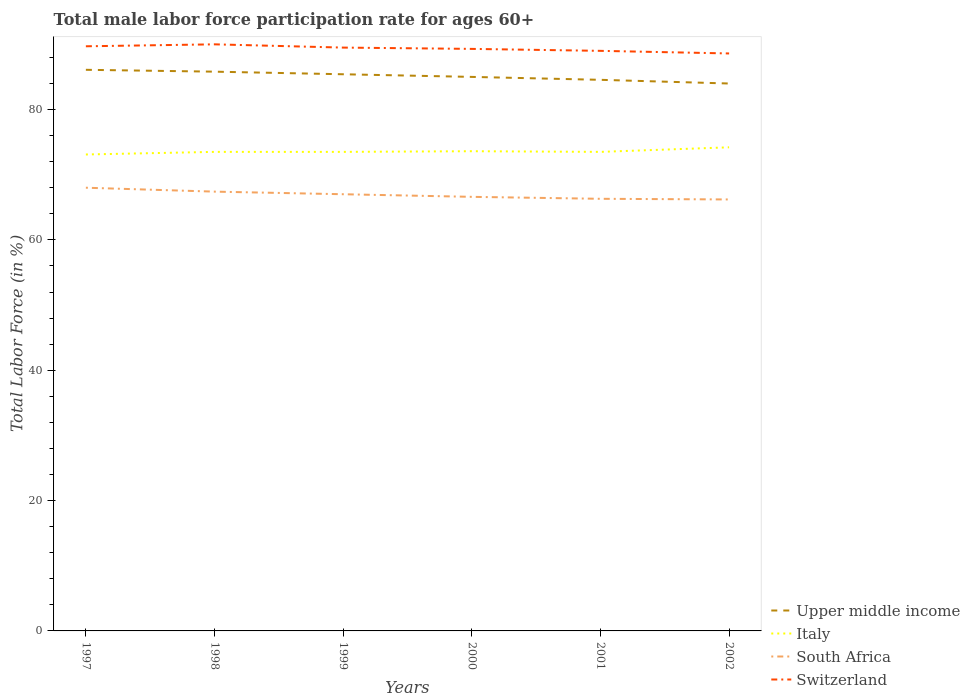Does the line corresponding to Italy intersect with the line corresponding to South Africa?
Ensure brevity in your answer.  No. Across all years, what is the maximum male labor force participation rate in Switzerland?
Your answer should be compact. 88.6. What is the total male labor force participation rate in Switzerland in the graph?
Your response must be concise. 0.5. What is the difference between the highest and the second highest male labor force participation rate in Italy?
Your response must be concise. 1.1. What is the difference between the highest and the lowest male labor force participation rate in Upper middle income?
Make the answer very short. 3. Is the male labor force participation rate in South Africa strictly greater than the male labor force participation rate in Upper middle income over the years?
Provide a short and direct response. Yes. Are the values on the major ticks of Y-axis written in scientific E-notation?
Offer a terse response. No. Does the graph contain grids?
Offer a very short reply. No. Where does the legend appear in the graph?
Your answer should be compact. Bottom right. How many legend labels are there?
Provide a short and direct response. 4. What is the title of the graph?
Your answer should be very brief. Total male labor force participation rate for ages 60+. What is the Total Labor Force (in %) in Upper middle income in 1997?
Offer a terse response. 86.09. What is the Total Labor Force (in %) in Italy in 1997?
Your answer should be very brief. 73.1. What is the Total Labor Force (in %) of Switzerland in 1997?
Provide a short and direct response. 89.7. What is the Total Labor Force (in %) in Upper middle income in 1998?
Give a very brief answer. 85.81. What is the Total Labor Force (in %) of Italy in 1998?
Give a very brief answer. 73.5. What is the Total Labor Force (in %) of South Africa in 1998?
Provide a short and direct response. 67.4. What is the Total Labor Force (in %) in Switzerland in 1998?
Offer a very short reply. 90. What is the Total Labor Force (in %) in Upper middle income in 1999?
Your answer should be compact. 85.41. What is the Total Labor Force (in %) of Italy in 1999?
Your answer should be very brief. 73.5. What is the Total Labor Force (in %) in South Africa in 1999?
Your answer should be compact. 67. What is the Total Labor Force (in %) in Switzerland in 1999?
Your response must be concise. 89.5. What is the Total Labor Force (in %) in Upper middle income in 2000?
Provide a short and direct response. 85. What is the Total Labor Force (in %) in Italy in 2000?
Give a very brief answer. 73.6. What is the Total Labor Force (in %) of South Africa in 2000?
Your response must be concise. 66.6. What is the Total Labor Force (in %) of Switzerland in 2000?
Your response must be concise. 89.3. What is the Total Labor Force (in %) in Upper middle income in 2001?
Your response must be concise. 84.55. What is the Total Labor Force (in %) of Italy in 2001?
Provide a succinct answer. 73.5. What is the Total Labor Force (in %) of South Africa in 2001?
Your answer should be very brief. 66.3. What is the Total Labor Force (in %) in Switzerland in 2001?
Offer a very short reply. 89. What is the Total Labor Force (in %) in Upper middle income in 2002?
Make the answer very short. 83.99. What is the Total Labor Force (in %) in Italy in 2002?
Provide a short and direct response. 74.2. What is the Total Labor Force (in %) of South Africa in 2002?
Your answer should be very brief. 66.2. What is the Total Labor Force (in %) of Switzerland in 2002?
Make the answer very short. 88.6. Across all years, what is the maximum Total Labor Force (in %) in Upper middle income?
Provide a succinct answer. 86.09. Across all years, what is the maximum Total Labor Force (in %) in Italy?
Provide a succinct answer. 74.2. Across all years, what is the maximum Total Labor Force (in %) of South Africa?
Your answer should be very brief. 68. Across all years, what is the maximum Total Labor Force (in %) of Switzerland?
Ensure brevity in your answer.  90. Across all years, what is the minimum Total Labor Force (in %) in Upper middle income?
Make the answer very short. 83.99. Across all years, what is the minimum Total Labor Force (in %) in Italy?
Keep it short and to the point. 73.1. Across all years, what is the minimum Total Labor Force (in %) of South Africa?
Offer a very short reply. 66.2. Across all years, what is the minimum Total Labor Force (in %) of Switzerland?
Provide a short and direct response. 88.6. What is the total Total Labor Force (in %) in Upper middle income in the graph?
Give a very brief answer. 510.85. What is the total Total Labor Force (in %) in Italy in the graph?
Make the answer very short. 441.4. What is the total Total Labor Force (in %) in South Africa in the graph?
Make the answer very short. 401.5. What is the total Total Labor Force (in %) of Switzerland in the graph?
Make the answer very short. 536.1. What is the difference between the Total Labor Force (in %) of Upper middle income in 1997 and that in 1998?
Make the answer very short. 0.29. What is the difference between the Total Labor Force (in %) of South Africa in 1997 and that in 1998?
Provide a short and direct response. 0.6. What is the difference between the Total Labor Force (in %) of Upper middle income in 1997 and that in 1999?
Make the answer very short. 0.68. What is the difference between the Total Labor Force (in %) of Switzerland in 1997 and that in 1999?
Provide a short and direct response. 0.2. What is the difference between the Total Labor Force (in %) of Upper middle income in 1997 and that in 2000?
Keep it short and to the point. 1.09. What is the difference between the Total Labor Force (in %) of Italy in 1997 and that in 2000?
Your response must be concise. -0.5. What is the difference between the Total Labor Force (in %) in Upper middle income in 1997 and that in 2001?
Provide a succinct answer. 1.54. What is the difference between the Total Labor Force (in %) in Switzerland in 1997 and that in 2001?
Offer a very short reply. 0.7. What is the difference between the Total Labor Force (in %) of Upper middle income in 1997 and that in 2002?
Keep it short and to the point. 2.1. What is the difference between the Total Labor Force (in %) in Switzerland in 1997 and that in 2002?
Your answer should be very brief. 1.1. What is the difference between the Total Labor Force (in %) in Upper middle income in 1998 and that in 1999?
Keep it short and to the point. 0.4. What is the difference between the Total Labor Force (in %) in Italy in 1998 and that in 1999?
Offer a very short reply. 0. What is the difference between the Total Labor Force (in %) in South Africa in 1998 and that in 1999?
Make the answer very short. 0.4. What is the difference between the Total Labor Force (in %) of Upper middle income in 1998 and that in 2000?
Ensure brevity in your answer.  0.8. What is the difference between the Total Labor Force (in %) in Switzerland in 1998 and that in 2000?
Provide a short and direct response. 0.7. What is the difference between the Total Labor Force (in %) of Upper middle income in 1998 and that in 2001?
Keep it short and to the point. 1.25. What is the difference between the Total Labor Force (in %) of South Africa in 1998 and that in 2001?
Offer a very short reply. 1.1. What is the difference between the Total Labor Force (in %) of Upper middle income in 1998 and that in 2002?
Provide a succinct answer. 1.82. What is the difference between the Total Labor Force (in %) in Italy in 1998 and that in 2002?
Provide a short and direct response. -0.7. What is the difference between the Total Labor Force (in %) of Switzerland in 1998 and that in 2002?
Ensure brevity in your answer.  1.4. What is the difference between the Total Labor Force (in %) in Upper middle income in 1999 and that in 2000?
Offer a very short reply. 0.41. What is the difference between the Total Labor Force (in %) in Italy in 1999 and that in 2000?
Keep it short and to the point. -0.1. What is the difference between the Total Labor Force (in %) in Switzerland in 1999 and that in 2000?
Offer a terse response. 0.2. What is the difference between the Total Labor Force (in %) in Upper middle income in 1999 and that in 2001?
Keep it short and to the point. 0.85. What is the difference between the Total Labor Force (in %) of South Africa in 1999 and that in 2001?
Provide a short and direct response. 0.7. What is the difference between the Total Labor Force (in %) of Switzerland in 1999 and that in 2001?
Ensure brevity in your answer.  0.5. What is the difference between the Total Labor Force (in %) of Upper middle income in 1999 and that in 2002?
Your response must be concise. 1.42. What is the difference between the Total Labor Force (in %) of Italy in 1999 and that in 2002?
Provide a succinct answer. -0.7. What is the difference between the Total Labor Force (in %) of Switzerland in 1999 and that in 2002?
Your answer should be very brief. 0.9. What is the difference between the Total Labor Force (in %) of Upper middle income in 2000 and that in 2001?
Keep it short and to the point. 0.45. What is the difference between the Total Labor Force (in %) of Switzerland in 2000 and that in 2001?
Your answer should be compact. 0.3. What is the difference between the Total Labor Force (in %) in Upper middle income in 2000 and that in 2002?
Your answer should be compact. 1.01. What is the difference between the Total Labor Force (in %) in South Africa in 2000 and that in 2002?
Offer a very short reply. 0.4. What is the difference between the Total Labor Force (in %) of Upper middle income in 2001 and that in 2002?
Keep it short and to the point. 0.57. What is the difference between the Total Labor Force (in %) of Italy in 2001 and that in 2002?
Keep it short and to the point. -0.7. What is the difference between the Total Labor Force (in %) of Upper middle income in 1997 and the Total Labor Force (in %) of Italy in 1998?
Offer a terse response. 12.59. What is the difference between the Total Labor Force (in %) in Upper middle income in 1997 and the Total Labor Force (in %) in South Africa in 1998?
Offer a terse response. 18.69. What is the difference between the Total Labor Force (in %) in Upper middle income in 1997 and the Total Labor Force (in %) in Switzerland in 1998?
Offer a terse response. -3.91. What is the difference between the Total Labor Force (in %) of Italy in 1997 and the Total Labor Force (in %) of South Africa in 1998?
Your response must be concise. 5.7. What is the difference between the Total Labor Force (in %) in Italy in 1997 and the Total Labor Force (in %) in Switzerland in 1998?
Make the answer very short. -16.9. What is the difference between the Total Labor Force (in %) of South Africa in 1997 and the Total Labor Force (in %) of Switzerland in 1998?
Make the answer very short. -22. What is the difference between the Total Labor Force (in %) in Upper middle income in 1997 and the Total Labor Force (in %) in Italy in 1999?
Provide a short and direct response. 12.59. What is the difference between the Total Labor Force (in %) of Upper middle income in 1997 and the Total Labor Force (in %) of South Africa in 1999?
Offer a very short reply. 19.09. What is the difference between the Total Labor Force (in %) of Upper middle income in 1997 and the Total Labor Force (in %) of Switzerland in 1999?
Offer a terse response. -3.41. What is the difference between the Total Labor Force (in %) in Italy in 1997 and the Total Labor Force (in %) in Switzerland in 1999?
Offer a terse response. -16.4. What is the difference between the Total Labor Force (in %) of South Africa in 1997 and the Total Labor Force (in %) of Switzerland in 1999?
Offer a terse response. -21.5. What is the difference between the Total Labor Force (in %) of Upper middle income in 1997 and the Total Labor Force (in %) of Italy in 2000?
Your answer should be compact. 12.49. What is the difference between the Total Labor Force (in %) of Upper middle income in 1997 and the Total Labor Force (in %) of South Africa in 2000?
Offer a very short reply. 19.49. What is the difference between the Total Labor Force (in %) in Upper middle income in 1997 and the Total Labor Force (in %) in Switzerland in 2000?
Your answer should be compact. -3.21. What is the difference between the Total Labor Force (in %) in Italy in 1997 and the Total Labor Force (in %) in South Africa in 2000?
Offer a very short reply. 6.5. What is the difference between the Total Labor Force (in %) in Italy in 1997 and the Total Labor Force (in %) in Switzerland in 2000?
Your answer should be very brief. -16.2. What is the difference between the Total Labor Force (in %) in South Africa in 1997 and the Total Labor Force (in %) in Switzerland in 2000?
Offer a terse response. -21.3. What is the difference between the Total Labor Force (in %) of Upper middle income in 1997 and the Total Labor Force (in %) of Italy in 2001?
Provide a succinct answer. 12.59. What is the difference between the Total Labor Force (in %) of Upper middle income in 1997 and the Total Labor Force (in %) of South Africa in 2001?
Ensure brevity in your answer.  19.79. What is the difference between the Total Labor Force (in %) of Upper middle income in 1997 and the Total Labor Force (in %) of Switzerland in 2001?
Ensure brevity in your answer.  -2.91. What is the difference between the Total Labor Force (in %) of Italy in 1997 and the Total Labor Force (in %) of South Africa in 2001?
Offer a very short reply. 6.8. What is the difference between the Total Labor Force (in %) of Italy in 1997 and the Total Labor Force (in %) of Switzerland in 2001?
Your answer should be very brief. -15.9. What is the difference between the Total Labor Force (in %) of South Africa in 1997 and the Total Labor Force (in %) of Switzerland in 2001?
Offer a terse response. -21. What is the difference between the Total Labor Force (in %) of Upper middle income in 1997 and the Total Labor Force (in %) of Italy in 2002?
Your answer should be very brief. 11.89. What is the difference between the Total Labor Force (in %) of Upper middle income in 1997 and the Total Labor Force (in %) of South Africa in 2002?
Provide a succinct answer. 19.89. What is the difference between the Total Labor Force (in %) of Upper middle income in 1997 and the Total Labor Force (in %) of Switzerland in 2002?
Provide a short and direct response. -2.51. What is the difference between the Total Labor Force (in %) in Italy in 1997 and the Total Labor Force (in %) in Switzerland in 2002?
Keep it short and to the point. -15.5. What is the difference between the Total Labor Force (in %) of South Africa in 1997 and the Total Labor Force (in %) of Switzerland in 2002?
Offer a terse response. -20.6. What is the difference between the Total Labor Force (in %) in Upper middle income in 1998 and the Total Labor Force (in %) in Italy in 1999?
Give a very brief answer. 12.31. What is the difference between the Total Labor Force (in %) of Upper middle income in 1998 and the Total Labor Force (in %) of South Africa in 1999?
Keep it short and to the point. 18.81. What is the difference between the Total Labor Force (in %) in Upper middle income in 1998 and the Total Labor Force (in %) in Switzerland in 1999?
Your answer should be compact. -3.69. What is the difference between the Total Labor Force (in %) in Italy in 1998 and the Total Labor Force (in %) in South Africa in 1999?
Keep it short and to the point. 6.5. What is the difference between the Total Labor Force (in %) of South Africa in 1998 and the Total Labor Force (in %) of Switzerland in 1999?
Your response must be concise. -22.1. What is the difference between the Total Labor Force (in %) of Upper middle income in 1998 and the Total Labor Force (in %) of Italy in 2000?
Provide a succinct answer. 12.21. What is the difference between the Total Labor Force (in %) of Upper middle income in 1998 and the Total Labor Force (in %) of South Africa in 2000?
Your answer should be very brief. 19.21. What is the difference between the Total Labor Force (in %) of Upper middle income in 1998 and the Total Labor Force (in %) of Switzerland in 2000?
Your response must be concise. -3.49. What is the difference between the Total Labor Force (in %) in Italy in 1998 and the Total Labor Force (in %) in South Africa in 2000?
Your answer should be very brief. 6.9. What is the difference between the Total Labor Force (in %) in Italy in 1998 and the Total Labor Force (in %) in Switzerland in 2000?
Offer a very short reply. -15.8. What is the difference between the Total Labor Force (in %) of South Africa in 1998 and the Total Labor Force (in %) of Switzerland in 2000?
Provide a succinct answer. -21.9. What is the difference between the Total Labor Force (in %) in Upper middle income in 1998 and the Total Labor Force (in %) in Italy in 2001?
Make the answer very short. 12.31. What is the difference between the Total Labor Force (in %) in Upper middle income in 1998 and the Total Labor Force (in %) in South Africa in 2001?
Your answer should be compact. 19.51. What is the difference between the Total Labor Force (in %) in Upper middle income in 1998 and the Total Labor Force (in %) in Switzerland in 2001?
Ensure brevity in your answer.  -3.19. What is the difference between the Total Labor Force (in %) in Italy in 1998 and the Total Labor Force (in %) in Switzerland in 2001?
Give a very brief answer. -15.5. What is the difference between the Total Labor Force (in %) in South Africa in 1998 and the Total Labor Force (in %) in Switzerland in 2001?
Provide a succinct answer. -21.6. What is the difference between the Total Labor Force (in %) in Upper middle income in 1998 and the Total Labor Force (in %) in Italy in 2002?
Keep it short and to the point. 11.61. What is the difference between the Total Labor Force (in %) in Upper middle income in 1998 and the Total Labor Force (in %) in South Africa in 2002?
Provide a succinct answer. 19.61. What is the difference between the Total Labor Force (in %) in Upper middle income in 1998 and the Total Labor Force (in %) in Switzerland in 2002?
Keep it short and to the point. -2.79. What is the difference between the Total Labor Force (in %) of Italy in 1998 and the Total Labor Force (in %) of South Africa in 2002?
Make the answer very short. 7.3. What is the difference between the Total Labor Force (in %) of Italy in 1998 and the Total Labor Force (in %) of Switzerland in 2002?
Provide a short and direct response. -15.1. What is the difference between the Total Labor Force (in %) of South Africa in 1998 and the Total Labor Force (in %) of Switzerland in 2002?
Offer a very short reply. -21.2. What is the difference between the Total Labor Force (in %) of Upper middle income in 1999 and the Total Labor Force (in %) of Italy in 2000?
Provide a short and direct response. 11.81. What is the difference between the Total Labor Force (in %) of Upper middle income in 1999 and the Total Labor Force (in %) of South Africa in 2000?
Offer a very short reply. 18.81. What is the difference between the Total Labor Force (in %) of Upper middle income in 1999 and the Total Labor Force (in %) of Switzerland in 2000?
Give a very brief answer. -3.89. What is the difference between the Total Labor Force (in %) of Italy in 1999 and the Total Labor Force (in %) of Switzerland in 2000?
Your response must be concise. -15.8. What is the difference between the Total Labor Force (in %) of South Africa in 1999 and the Total Labor Force (in %) of Switzerland in 2000?
Provide a short and direct response. -22.3. What is the difference between the Total Labor Force (in %) in Upper middle income in 1999 and the Total Labor Force (in %) in Italy in 2001?
Offer a terse response. 11.91. What is the difference between the Total Labor Force (in %) of Upper middle income in 1999 and the Total Labor Force (in %) of South Africa in 2001?
Offer a terse response. 19.11. What is the difference between the Total Labor Force (in %) in Upper middle income in 1999 and the Total Labor Force (in %) in Switzerland in 2001?
Offer a very short reply. -3.59. What is the difference between the Total Labor Force (in %) of Italy in 1999 and the Total Labor Force (in %) of Switzerland in 2001?
Give a very brief answer. -15.5. What is the difference between the Total Labor Force (in %) in Upper middle income in 1999 and the Total Labor Force (in %) in Italy in 2002?
Your answer should be very brief. 11.21. What is the difference between the Total Labor Force (in %) in Upper middle income in 1999 and the Total Labor Force (in %) in South Africa in 2002?
Give a very brief answer. 19.21. What is the difference between the Total Labor Force (in %) in Upper middle income in 1999 and the Total Labor Force (in %) in Switzerland in 2002?
Provide a succinct answer. -3.19. What is the difference between the Total Labor Force (in %) of Italy in 1999 and the Total Labor Force (in %) of Switzerland in 2002?
Offer a terse response. -15.1. What is the difference between the Total Labor Force (in %) of South Africa in 1999 and the Total Labor Force (in %) of Switzerland in 2002?
Make the answer very short. -21.6. What is the difference between the Total Labor Force (in %) in Upper middle income in 2000 and the Total Labor Force (in %) in Italy in 2001?
Give a very brief answer. 11.5. What is the difference between the Total Labor Force (in %) in Upper middle income in 2000 and the Total Labor Force (in %) in South Africa in 2001?
Give a very brief answer. 18.7. What is the difference between the Total Labor Force (in %) of Upper middle income in 2000 and the Total Labor Force (in %) of Switzerland in 2001?
Ensure brevity in your answer.  -4. What is the difference between the Total Labor Force (in %) of Italy in 2000 and the Total Labor Force (in %) of South Africa in 2001?
Provide a succinct answer. 7.3. What is the difference between the Total Labor Force (in %) of Italy in 2000 and the Total Labor Force (in %) of Switzerland in 2001?
Ensure brevity in your answer.  -15.4. What is the difference between the Total Labor Force (in %) in South Africa in 2000 and the Total Labor Force (in %) in Switzerland in 2001?
Offer a terse response. -22.4. What is the difference between the Total Labor Force (in %) of Upper middle income in 2000 and the Total Labor Force (in %) of Italy in 2002?
Provide a succinct answer. 10.8. What is the difference between the Total Labor Force (in %) of Upper middle income in 2000 and the Total Labor Force (in %) of South Africa in 2002?
Provide a succinct answer. 18.8. What is the difference between the Total Labor Force (in %) of Upper middle income in 2000 and the Total Labor Force (in %) of Switzerland in 2002?
Give a very brief answer. -3.6. What is the difference between the Total Labor Force (in %) in Italy in 2000 and the Total Labor Force (in %) in South Africa in 2002?
Your answer should be compact. 7.4. What is the difference between the Total Labor Force (in %) in South Africa in 2000 and the Total Labor Force (in %) in Switzerland in 2002?
Ensure brevity in your answer.  -22. What is the difference between the Total Labor Force (in %) of Upper middle income in 2001 and the Total Labor Force (in %) of Italy in 2002?
Provide a short and direct response. 10.35. What is the difference between the Total Labor Force (in %) of Upper middle income in 2001 and the Total Labor Force (in %) of South Africa in 2002?
Your answer should be compact. 18.35. What is the difference between the Total Labor Force (in %) in Upper middle income in 2001 and the Total Labor Force (in %) in Switzerland in 2002?
Give a very brief answer. -4.05. What is the difference between the Total Labor Force (in %) of Italy in 2001 and the Total Labor Force (in %) of South Africa in 2002?
Your answer should be compact. 7.3. What is the difference between the Total Labor Force (in %) in Italy in 2001 and the Total Labor Force (in %) in Switzerland in 2002?
Your answer should be compact. -15.1. What is the difference between the Total Labor Force (in %) in South Africa in 2001 and the Total Labor Force (in %) in Switzerland in 2002?
Keep it short and to the point. -22.3. What is the average Total Labor Force (in %) in Upper middle income per year?
Keep it short and to the point. 85.14. What is the average Total Labor Force (in %) of Italy per year?
Make the answer very short. 73.57. What is the average Total Labor Force (in %) in South Africa per year?
Provide a short and direct response. 66.92. What is the average Total Labor Force (in %) in Switzerland per year?
Offer a terse response. 89.35. In the year 1997, what is the difference between the Total Labor Force (in %) of Upper middle income and Total Labor Force (in %) of Italy?
Your response must be concise. 12.99. In the year 1997, what is the difference between the Total Labor Force (in %) of Upper middle income and Total Labor Force (in %) of South Africa?
Your response must be concise. 18.09. In the year 1997, what is the difference between the Total Labor Force (in %) in Upper middle income and Total Labor Force (in %) in Switzerland?
Offer a terse response. -3.61. In the year 1997, what is the difference between the Total Labor Force (in %) in Italy and Total Labor Force (in %) in Switzerland?
Keep it short and to the point. -16.6. In the year 1997, what is the difference between the Total Labor Force (in %) of South Africa and Total Labor Force (in %) of Switzerland?
Give a very brief answer. -21.7. In the year 1998, what is the difference between the Total Labor Force (in %) of Upper middle income and Total Labor Force (in %) of Italy?
Provide a succinct answer. 12.31. In the year 1998, what is the difference between the Total Labor Force (in %) in Upper middle income and Total Labor Force (in %) in South Africa?
Your response must be concise. 18.41. In the year 1998, what is the difference between the Total Labor Force (in %) of Upper middle income and Total Labor Force (in %) of Switzerland?
Keep it short and to the point. -4.19. In the year 1998, what is the difference between the Total Labor Force (in %) in Italy and Total Labor Force (in %) in South Africa?
Give a very brief answer. 6.1. In the year 1998, what is the difference between the Total Labor Force (in %) of Italy and Total Labor Force (in %) of Switzerland?
Provide a short and direct response. -16.5. In the year 1998, what is the difference between the Total Labor Force (in %) of South Africa and Total Labor Force (in %) of Switzerland?
Offer a very short reply. -22.6. In the year 1999, what is the difference between the Total Labor Force (in %) in Upper middle income and Total Labor Force (in %) in Italy?
Your response must be concise. 11.91. In the year 1999, what is the difference between the Total Labor Force (in %) in Upper middle income and Total Labor Force (in %) in South Africa?
Ensure brevity in your answer.  18.41. In the year 1999, what is the difference between the Total Labor Force (in %) in Upper middle income and Total Labor Force (in %) in Switzerland?
Your answer should be compact. -4.09. In the year 1999, what is the difference between the Total Labor Force (in %) in Italy and Total Labor Force (in %) in South Africa?
Your answer should be compact. 6.5. In the year 1999, what is the difference between the Total Labor Force (in %) in South Africa and Total Labor Force (in %) in Switzerland?
Provide a succinct answer. -22.5. In the year 2000, what is the difference between the Total Labor Force (in %) of Upper middle income and Total Labor Force (in %) of Italy?
Offer a very short reply. 11.4. In the year 2000, what is the difference between the Total Labor Force (in %) of Upper middle income and Total Labor Force (in %) of South Africa?
Your answer should be compact. 18.4. In the year 2000, what is the difference between the Total Labor Force (in %) in Upper middle income and Total Labor Force (in %) in Switzerland?
Offer a very short reply. -4.3. In the year 2000, what is the difference between the Total Labor Force (in %) in Italy and Total Labor Force (in %) in Switzerland?
Offer a terse response. -15.7. In the year 2000, what is the difference between the Total Labor Force (in %) in South Africa and Total Labor Force (in %) in Switzerland?
Provide a short and direct response. -22.7. In the year 2001, what is the difference between the Total Labor Force (in %) of Upper middle income and Total Labor Force (in %) of Italy?
Your response must be concise. 11.05. In the year 2001, what is the difference between the Total Labor Force (in %) in Upper middle income and Total Labor Force (in %) in South Africa?
Your answer should be very brief. 18.25. In the year 2001, what is the difference between the Total Labor Force (in %) in Upper middle income and Total Labor Force (in %) in Switzerland?
Offer a very short reply. -4.45. In the year 2001, what is the difference between the Total Labor Force (in %) of Italy and Total Labor Force (in %) of Switzerland?
Give a very brief answer. -15.5. In the year 2001, what is the difference between the Total Labor Force (in %) in South Africa and Total Labor Force (in %) in Switzerland?
Your answer should be compact. -22.7. In the year 2002, what is the difference between the Total Labor Force (in %) in Upper middle income and Total Labor Force (in %) in Italy?
Provide a succinct answer. 9.79. In the year 2002, what is the difference between the Total Labor Force (in %) in Upper middle income and Total Labor Force (in %) in South Africa?
Your answer should be compact. 17.79. In the year 2002, what is the difference between the Total Labor Force (in %) in Upper middle income and Total Labor Force (in %) in Switzerland?
Your answer should be very brief. -4.61. In the year 2002, what is the difference between the Total Labor Force (in %) of Italy and Total Labor Force (in %) of South Africa?
Keep it short and to the point. 8. In the year 2002, what is the difference between the Total Labor Force (in %) of Italy and Total Labor Force (in %) of Switzerland?
Your answer should be compact. -14.4. In the year 2002, what is the difference between the Total Labor Force (in %) of South Africa and Total Labor Force (in %) of Switzerland?
Provide a succinct answer. -22.4. What is the ratio of the Total Labor Force (in %) of South Africa in 1997 to that in 1998?
Your answer should be compact. 1.01. What is the ratio of the Total Labor Force (in %) in Switzerland in 1997 to that in 1998?
Ensure brevity in your answer.  1. What is the ratio of the Total Labor Force (in %) in South Africa in 1997 to that in 1999?
Make the answer very short. 1.01. What is the ratio of the Total Labor Force (in %) in Switzerland in 1997 to that in 1999?
Provide a short and direct response. 1. What is the ratio of the Total Labor Force (in %) in Upper middle income in 1997 to that in 2000?
Provide a succinct answer. 1.01. What is the ratio of the Total Labor Force (in %) of South Africa in 1997 to that in 2000?
Your answer should be very brief. 1.02. What is the ratio of the Total Labor Force (in %) of Upper middle income in 1997 to that in 2001?
Your answer should be compact. 1.02. What is the ratio of the Total Labor Force (in %) in Italy in 1997 to that in 2001?
Keep it short and to the point. 0.99. What is the ratio of the Total Labor Force (in %) of South Africa in 1997 to that in 2001?
Provide a short and direct response. 1.03. What is the ratio of the Total Labor Force (in %) of Switzerland in 1997 to that in 2001?
Your answer should be compact. 1.01. What is the ratio of the Total Labor Force (in %) of Italy in 1997 to that in 2002?
Offer a terse response. 0.99. What is the ratio of the Total Labor Force (in %) of South Africa in 1997 to that in 2002?
Offer a very short reply. 1.03. What is the ratio of the Total Labor Force (in %) in Switzerland in 1997 to that in 2002?
Ensure brevity in your answer.  1.01. What is the ratio of the Total Labor Force (in %) in South Africa in 1998 to that in 1999?
Ensure brevity in your answer.  1.01. What is the ratio of the Total Labor Force (in %) in Switzerland in 1998 to that in 1999?
Provide a succinct answer. 1.01. What is the ratio of the Total Labor Force (in %) of Upper middle income in 1998 to that in 2000?
Provide a short and direct response. 1.01. What is the ratio of the Total Labor Force (in %) of Italy in 1998 to that in 2000?
Offer a very short reply. 1. What is the ratio of the Total Labor Force (in %) of South Africa in 1998 to that in 2000?
Provide a succinct answer. 1.01. What is the ratio of the Total Labor Force (in %) of Switzerland in 1998 to that in 2000?
Provide a short and direct response. 1.01. What is the ratio of the Total Labor Force (in %) of Upper middle income in 1998 to that in 2001?
Your answer should be compact. 1.01. What is the ratio of the Total Labor Force (in %) of Italy in 1998 to that in 2001?
Make the answer very short. 1. What is the ratio of the Total Labor Force (in %) in South Africa in 1998 to that in 2001?
Ensure brevity in your answer.  1.02. What is the ratio of the Total Labor Force (in %) of Switzerland in 1998 to that in 2001?
Keep it short and to the point. 1.01. What is the ratio of the Total Labor Force (in %) of Upper middle income in 1998 to that in 2002?
Provide a succinct answer. 1.02. What is the ratio of the Total Labor Force (in %) of Italy in 1998 to that in 2002?
Offer a terse response. 0.99. What is the ratio of the Total Labor Force (in %) of South Africa in 1998 to that in 2002?
Offer a very short reply. 1.02. What is the ratio of the Total Labor Force (in %) of Switzerland in 1998 to that in 2002?
Your response must be concise. 1.02. What is the ratio of the Total Labor Force (in %) in Italy in 1999 to that in 2000?
Give a very brief answer. 1. What is the ratio of the Total Labor Force (in %) of Upper middle income in 1999 to that in 2001?
Make the answer very short. 1.01. What is the ratio of the Total Labor Force (in %) in Italy in 1999 to that in 2001?
Provide a succinct answer. 1. What is the ratio of the Total Labor Force (in %) of South Africa in 1999 to that in 2001?
Offer a terse response. 1.01. What is the ratio of the Total Labor Force (in %) in Switzerland in 1999 to that in 2001?
Your answer should be compact. 1.01. What is the ratio of the Total Labor Force (in %) in Upper middle income in 1999 to that in 2002?
Provide a short and direct response. 1.02. What is the ratio of the Total Labor Force (in %) of Italy in 1999 to that in 2002?
Ensure brevity in your answer.  0.99. What is the ratio of the Total Labor Force (in %) of South Africa in 1999 to that in 2002?
Offer a terse response. 1.01. What is the ratio of the Total Labor Force (in %) in Switzerland in 1999 to that in 2002?
Your answer should be very brief. 1.01. What is the ratio of the Total Labor Force (in %) in Italy in 2000 to that in 2001?
Provide a short and direct response. 1. What is the ratio of the Total Labor Force (in %) of South Africa in 2000 to that in 2001?
Give a very brief answer. 1. What is the ratio of the Total Labor Force (in %) of Switzerland in 2000 to that in 2001?
Offer a very short reply. 1. What is the ratio of the Total Labor Force (in %) of Upper middle income in 2000 to that in 2002?
Offer a very short reply. 1.01. What is the ratio of the Total Labor Force (in %) of Italy in 2000 to that in 2002?
Make the answer very short. 0.99. What is the ratio of the Total Labor Force (in %) of South Africa in 2000 to that in 2002?
Keep it short and to the point. 1.01. What is the ratio of the Total Labor Force (in %) of Switzerland in 2000 to that in 2002?
Keep it short and to the point. 1.01. What is the ratio of the Total Labor Force (in %) of Upper middle income in 2001 to that in 2002?
Provide a short and direct response. 1.01. What is the ratio of the Total Labor Force (in %) of Italy in 2001 to that in 2002?
Keep it short and to the point. 0.99. What is the ratio of the Total Labor Force (in %) of South Africa in 2001 to that in 2002?
Ensure brevity in your answer.  1. What is the ratio of the Total Labor Force (in %) of Switzerland in 2001 to that in 2002?
Your response must be concise. 1. What is the difference between the highest and the second highest Total Labor Force (in %) of Upper middle income?
Provide a succinct answer. 0.29. What is the difference between the highest and the second highest Total Labor Force (in %) of South Africa?
Keep it short and to the point. 0.6. What is the difference between the highest and the lowest Total Labor Force (in %) of Upper middle income?
Your answer should be very brief. 2.1. What is the difference between the highest and the lowest Total Labor Force (in %) of Italy?
Your response must be concise. 1.1. What is the difference between the highest and the lowest Total Labor Force (in %) of Switzerland?
Your answer should be very brief. 1.4. 